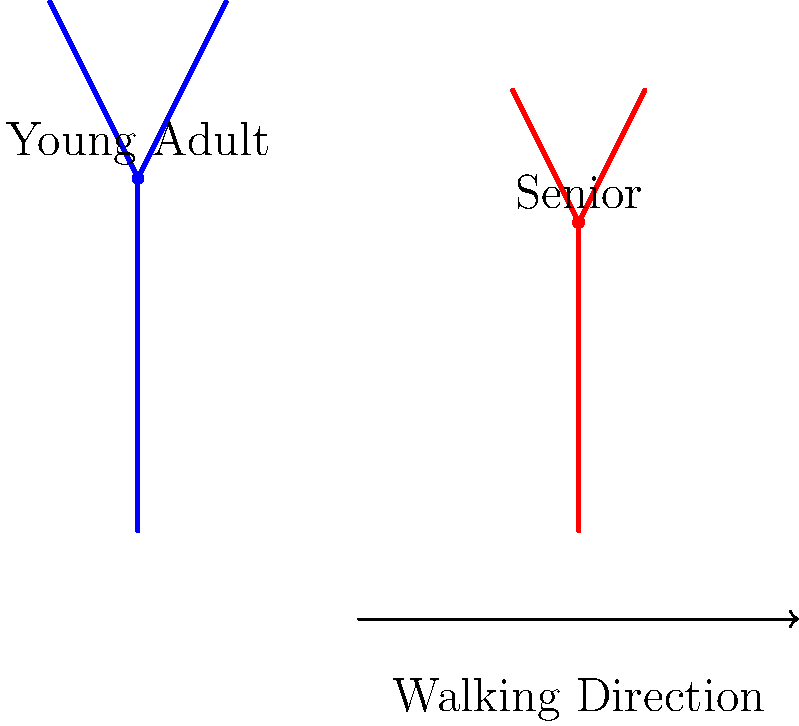In the stick figure animation comparing the walking gaits of a young adult and a senior, what key difference can be observed in their posture, and how might this relate to the themes of aging and resilience often found in mid-20th century literature? 1. Observe the stick figures: The blue figure represents a young adult, while the red figure represents a senior.

2. Analyze posture differences:
   a. The young adult's stick figure is more upright and taller.
   b. The senior's stick figure shows a slight forward lean and is shorter.

3. Interpret the biomechanical implications:
   a. The senior's posture indicates potential loss of muscle strength and flexibility.
   b. The forward lean may be a compensatory mechanism for balance.

4. Consider the walking gait:
   a. The senior's steps (indicated by leg position) appear shorter.
   b. This suggests a more cautious, slower gait in older adults.

5. Relate to mid-20th century literature themes:
   a. Aging is often portrayed as a process of physical decline but also of gained wisdom.
   b. The senior's altered gait represents physical changes, while their continued mobility symbolizes resilience.
   c. Authors like Ernest Hemingway or John Steinbeck often explored themes of human endurance in the face of physical challenges.

6. Draw parallels to character development:
   a. The physical changes in gait mirror the internal growth of characters in literature.
   b. Just as the senior adapts their walking style, literary characters often adapt to life's challenges.

This comparison invites reflection on the inevitability of aging and the strength of the human spirit, themes prevalent in classic mid-20th century literature.
Answer: The senior figure shows a forward lean and shorter stature, symbolizing physical aging but continued mobility, reflecting themes of resilience in mid-20th century literature. 